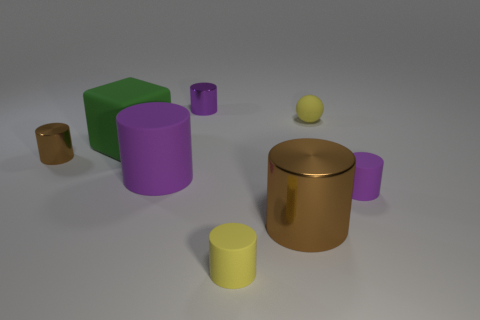Subtract all brown cylinders. How many were subtracted if there are1brown cylinders left? 1 Subtract all yellow blocks. How many purple cylinders are left? 3 Subtract all brown cylinders. How many cylinders are left? 4 Subtract all large cylinders. How many cylinders are left? 4 Subtract all gray cylinders. Subtract all red balls. How many cylinders are left? 6 Add 1 small yellow shiny spheres. How many objects exist? 9 Subtract all cylinders. How many objects are left? 2 Add 7 purple rubber balls. How many purple rubber balls exist? 7 Subtract 1 green cubes. How many objects are left? 7 Subtract all cyan objects. Subtract all big purple things. How many objects are left? 7 